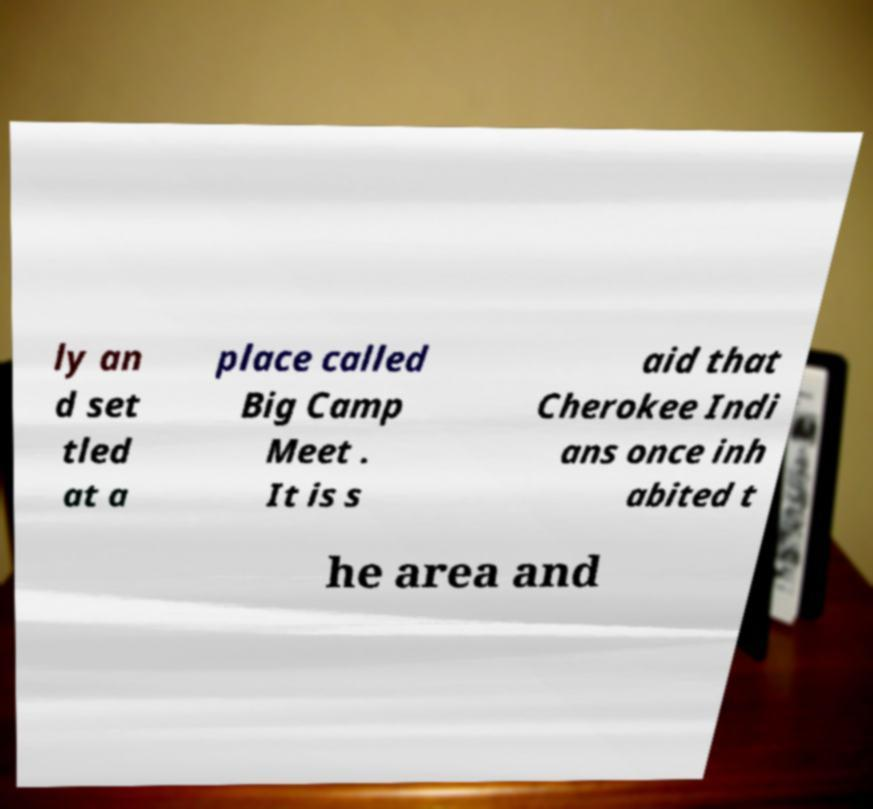What messages or text are displayed in this image? I need them in a readable, typed format. ly an d set tled at a place called Big Camp Meet . It is s aid that Cherokee Indi ans once inh abited t he area and 